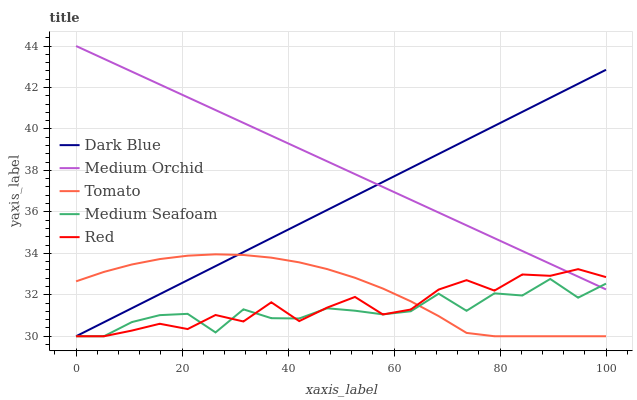Does Dark Blue have the minimum area under the curve?
Answer yes or no. No. Does Dark Blue have the maximum area under the curve?
Answer yes or no. No. Is Medium Orchid the smoothest?
Answer yes or no. No. Is Medium Orchid the roughest?
Answer yes or no. No. Does Medium Orchid have the lowest value?
Answer yes or no. No. Does Dark Blue have the highest value?
Answer yes or no. No. Is Tomato less than Medium Orchid?
Answer yes or no. Yes. Is Medium Orchid greater than Tomato?
Answer yes or no. Yes. Does Tomato intersect Medium Orchid?
Answer yes or no. No. 